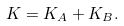<formula> <loc_0><loc_0><loc_500><loc_500>K = K _ { A } + K _ { B } .</formula> 